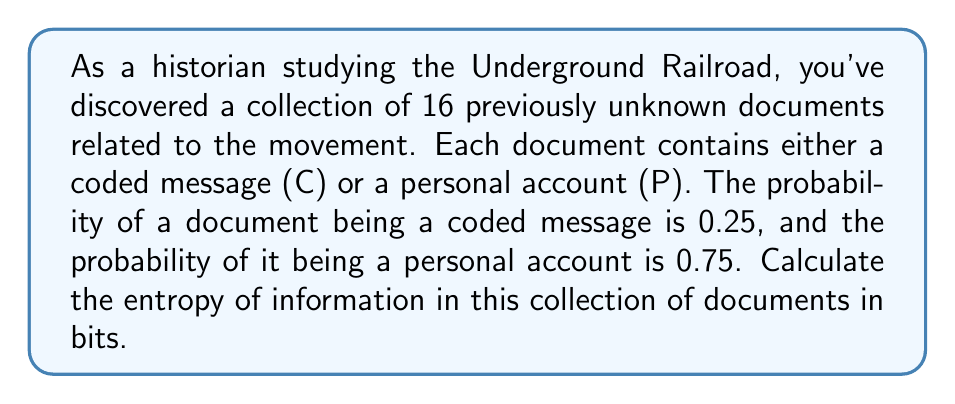Teach me how to tackle this problem. To calculate the entropy of information in this collection of documents, we'll use Shannon's entropy formula:

$$H = -\sum_{i=1}^n p_i \log_2(p_i)$$

Where:
$H$ is the entropy in bits
$p_i$ is the probability of each outcome
$n$ is the number of possible outcomes

In this case, we have two possible outcomes:
1. Coded message (C) with probability $p_C = 0.25$
2. Personal account (P) with probability $p_P = 0.75$

Let's calculate the entropy:

$$\begin{align*}
H &= -[p_C \log_2(p_C) + p_P \log_2(p_P)] \\[10pt]
&= -[0.25 \log_2(0.25) + 0.75 \log_2(0.75)] \\[10pt]
&= -[0.25 \cdot (-2) + 0.75 \cdot (-0.415)] \\[10pt]
&= -[-0.5 - 0.31125] \\[10pt]
&= 0.81125 \text{ bits}
\end{align*}$$

This result represents the average amount of information contained in each document in the collection.
Answer: 0.81125 bits 